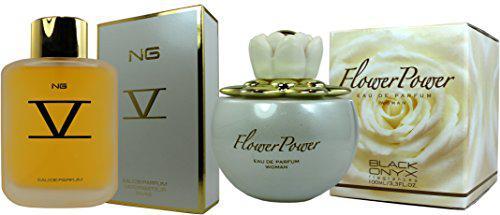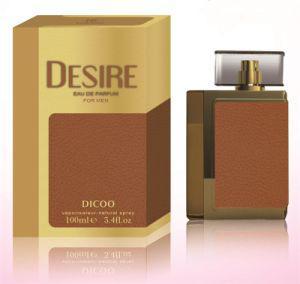The first image is the image on the left, the second image is the image on the right. Given the left and right images, does the statement "Each image shows two cologne products, at least one of which is a bottle of yellowish liquid with a square lid." hold true? Answer yes or no. No. The first image is the image on the left, the second image is the image on the right. Analyze the images presented: Is the assertion "An image shows one square-bottled fragrance on the right side of its gold box, and not overlapping the box." valid? Answer yes or no. Yes. 